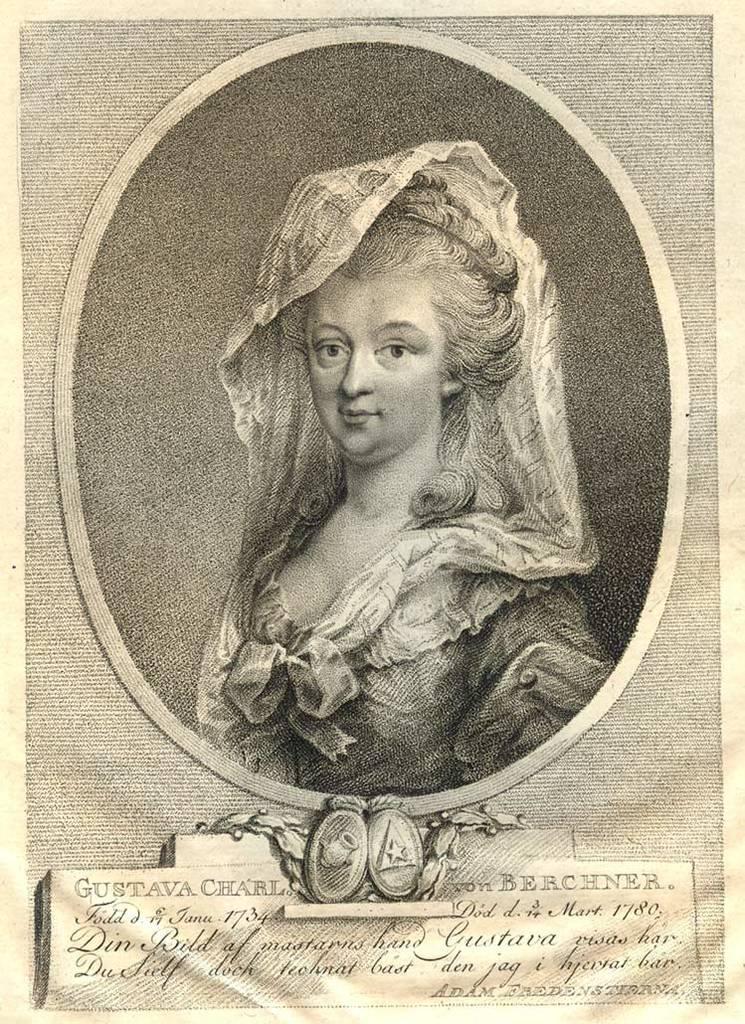Could you give a brief overview of what you see in this image? In this image I can see the paper. In the paper I can see the person with the dress and some text is written on the paper. And it is in black and cream color. 